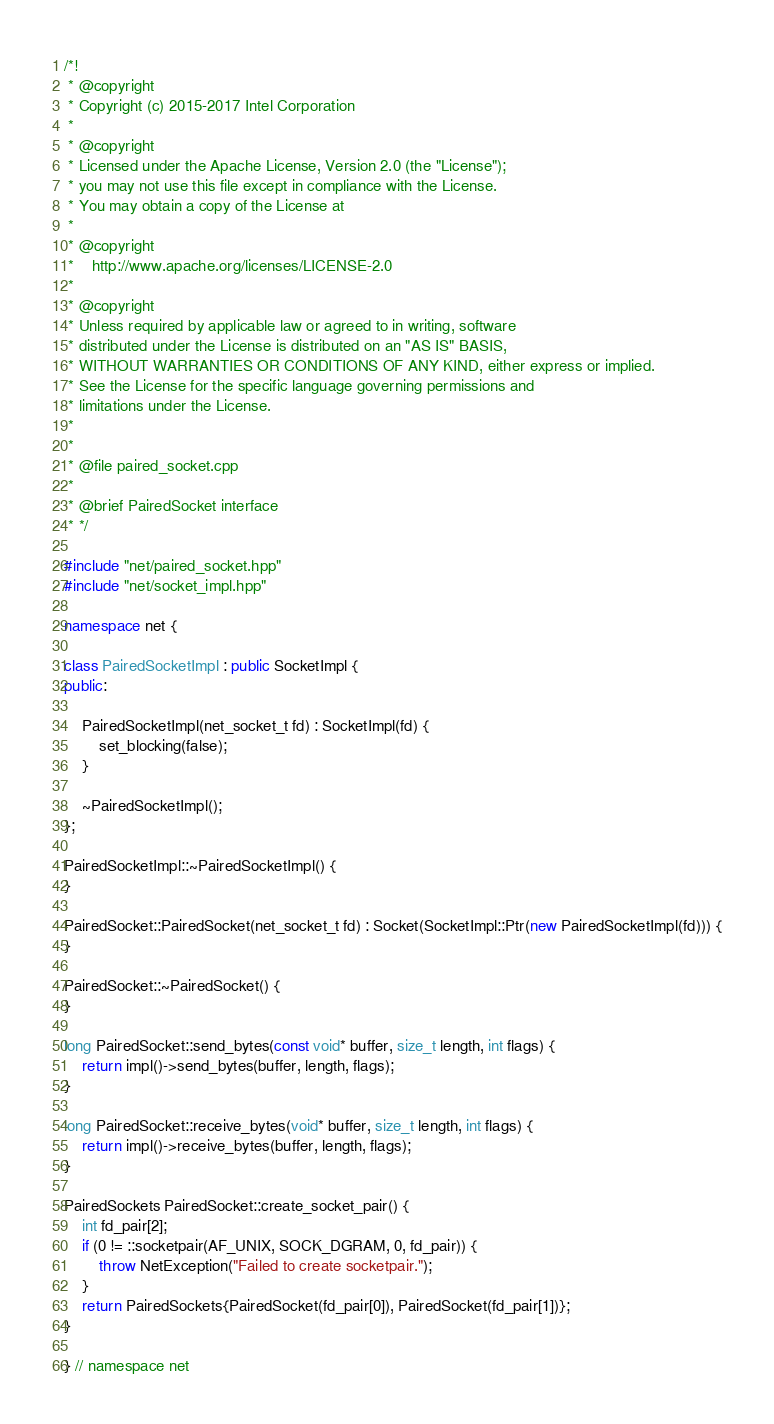<code> <loc_0><loc_0><loc_500><loc_500><_C++_>/*!
 * @copyright
 * Copyright (c) 2015-2017 Intel Corporation
 *
 * @copyright
 * Licensed under the Apache License, Version 2.0 (the "License");
 * you may not use this file except in compliance with the License.
 * You may obtain a copy of the License at
 *
 * @copyright
 *    http://www.apache.org/licenses/LICENSE-2.0
 *
 * @copyright
 * Unless required by applicable law or agreed to in writing, software
 * distributed under the License is distributed on an "AS IS" BASIS,
 * WITHOUT WARRANTIES OR CONDITIONS OF ANY KIND, either express or implied.
 * See the License for the specific language governing permissions and
 * limitations under the License.
 *
 *
 * @file paired_socket.cpp
 *
 * @brief PairedSocket interface
 * */

#include "net/paired_socket.hpp"
#include "net/socket_impl.hpp"

namespace net {

class PairedSocketImpl : public SocketImpl {
public:

    PairedSocketImpl(net_socket_t fd) : SocketImpl(fd) {
        set_blocking(false);
    }

    ~PairedSocketImpl();
};

PairedSocketImpl::~PairedSocketImpl() {
}

PairedSocket::PairedSocket(net_socket_t fd) : Socket(SocketImpl::Ptr(new PairedSocketImpl(fd))) {
}

PairedSocket::~PairedSocket() {
}

long PairedSocket::send_bytes(const void* buffer, size_t length, int flags) {
    return impl()->send_bytes(buffer, length, flags);
}

long PairedSocket::receive_bytes(void* buffer, size_t length, int flags) {
    return impl()->receive_bytes(buffer, length, flags);
}

PairedSockets PairedSocket::create_socket_pair() {
    int fd_pair[2];
    if (0 != ::socketpair(AF_UNIX, SOCK_DGRAM, 0, fd_pair)) {
        throw NetException("Failed to create socketpair.");
    }
    return PairedSockets{PairedSocket(fd_pair[0]), PairedSocket(fd_pair[1])};
}

} // namespace net
</code> 